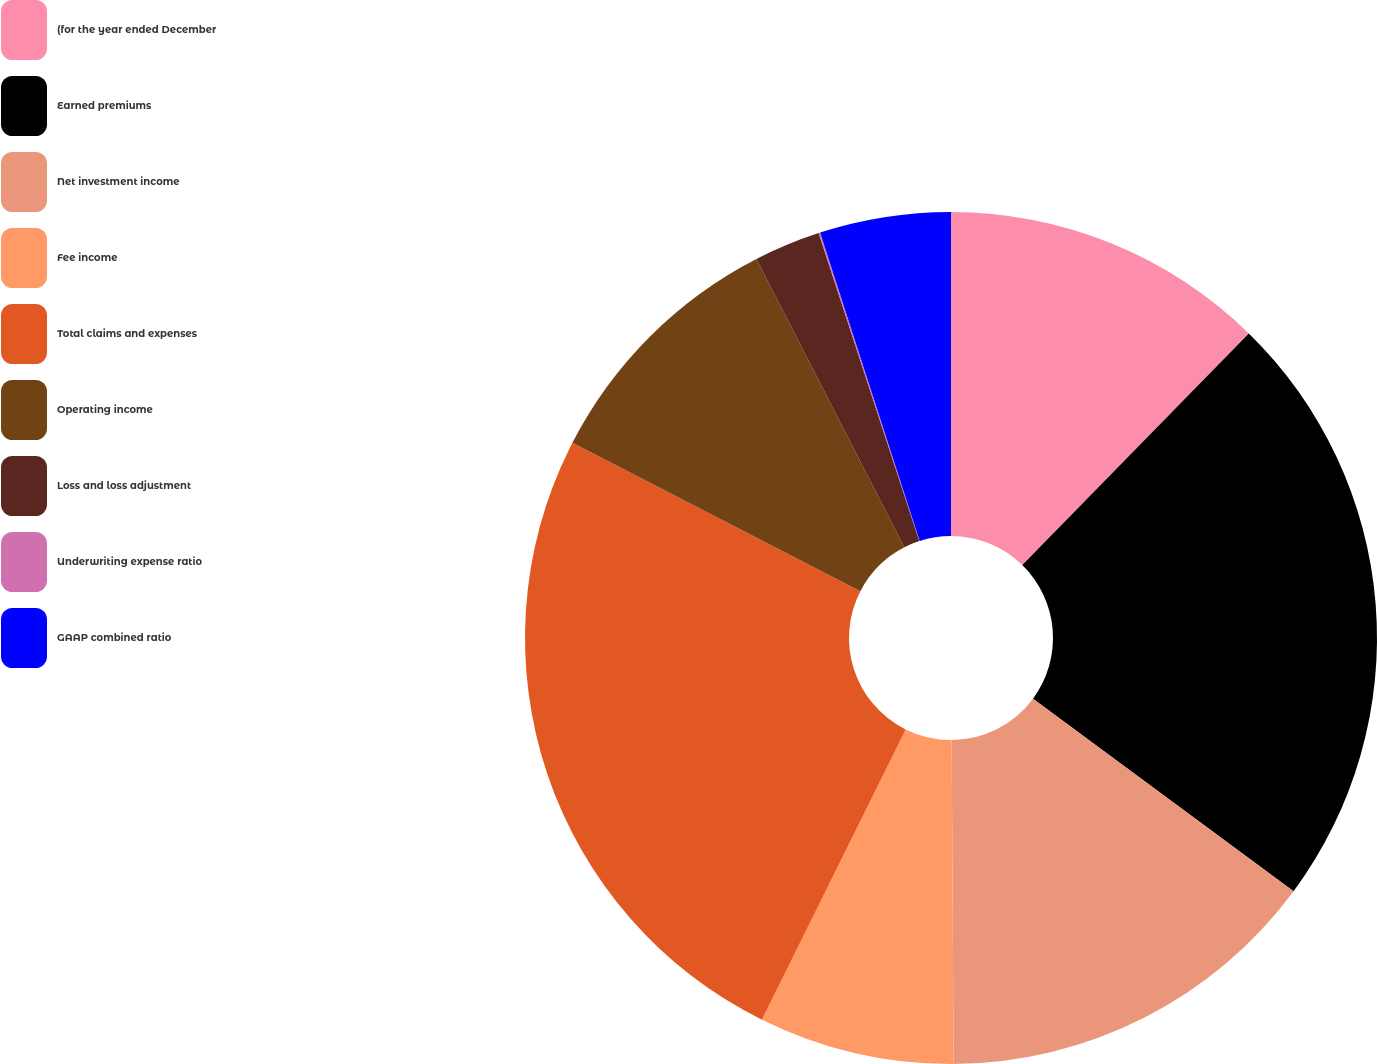Convert chart to OTSL. <chart><loc_0><loc_0><loc_500><loc_500><pie_chart><fcel>(for the year ended December<fcel>Earned premiums<fcel>Net investment income<fcel>Fee income<fcel>Total claims and expenses<fcel>Operating income<fcel>Loss and loss adjustment<fcel>Underwriting expense ratio<fcel>GAAP combined ratio<nl><fcel>12.32%<fcel>22.81%<fcel>14.77%<fcel>7.42%<fcel>25.26%<fcel>9.87%<fcel>2.52%<fcel>0.06%<fcel>4.97%<nl></chart> 